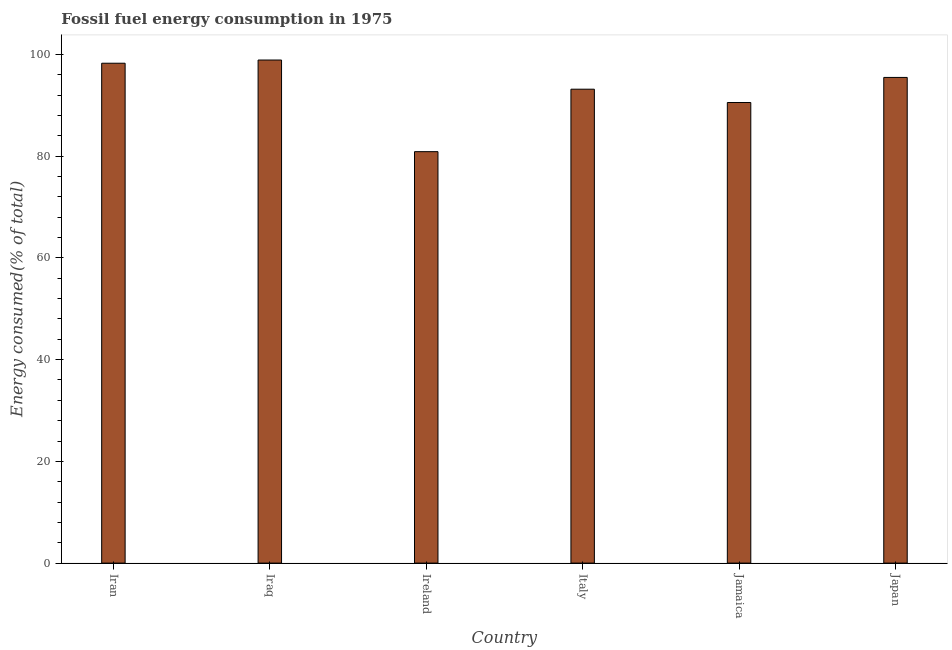What is the title of the graph?
Offer a terse response. Fossil fuel energy consumption in 1975. What is the label or title of the Y-axis?
Keep it short and to the point. Energy consumed(% of total). What is the fossil fuel energy consumption in Italy?
Make the answer very short. 93.16. Across all countries, what is the maximum fossil fuel energy consumption?
Offer a very short reply. 98.9. Across all countries, what is the minimum fossil fuel energy consumption?
Provide a short and direct response. 80.88. In which country was the fossil fuel energy consumption maximum?
Your answer should be compact. Iraq. In which country was the fossil fuel energy consumption minimum?
Provide a succinct answer. Ireland. What is the sum of the fossil fuel energy consumption?
Give a very brief answer. 557.23. What is the difference between the fossil fuel energy consumption in Iraq and Italy?
Offer a terse response. 5.73. What is the average fossil fuel energy consumption per country?
Your answer should be very brief. 92.87. What is the median fossil fuel energy consumption?
Provide a short and direct response. 94.32. What is the ratio of the fossil fuel energy consumption in Iraq to that in Jamaica?
Your response must be concise. 1.09. What is the difference between the highest and the second highest fossil fuel energy consumption?
Keep it short and to the point. 0.63. Is the sum of the fossil fuel energy consumption in Iraq and Italy greater than the maximum fossil fuel energy consumption across all countries?
Offer a terse response. Yes. What is the difference between the highest and the lowest fossil fuel energy consumption?
Your answer should be compact. 18.01. In how many countries, is the fossil fuel energy consumption greater than the average fossil fuel energy consumption taken over all countries?
Offer a very short reply. 4. How many countries are there in the graph?
Offer a very short reply. 6. Are the values on the major ticks of Y-axis written in scientific E-notation?
Your answer should be very brief. No. What is the Energy consumed(% of total) in Iran?
Provide a short and direct response. 98.27. What is the Energy consumed(% of total) in Iraq?
Give a very brief answer. 98.9. What is the Energy consumed(% of total) in Ireland?
Your answer should be very brief. 80.88. What is the Energy consumed(% of total) in Italy?
Give a very brief answer. 93.16. What is the Energy consumed(% of total) of Jamaica?
Your answer should be very brief. 90.54. What is the Energy consumed(% of total) of Japan?
Provide a short and direct response. 95.47. What is the difference between the Energy consumed(% of total) in Iran and Iraq?
Provide a short and direct response. -0.63. What is the difference between the Energy consumed(% of total) in Iran and Ireland?
Provide a succinct answer. 17.39. What is the difference between the Energy consumed(% of total) in Iran and Italy?
Provide a short and direct response. 5.11. What is the difference between the Energy consumed(% of total) in Iran and Jamaica?
Offer a very short reply. 7.72. What is the difference between the Energy consumed(% of total) in Iran and Japan?
Offer a terse response. 2.79. What is the difference between the Energy consumed(% of total) in Iraq and Ireland?
Make the answer very short. 18.01. What is the difference between the Energy consumed(% of total) in Iraq and Italy?
Your answer should be very brief. 5.73. What is the difference between the Energy consumed(% of total) in Iraq and Jamaica?
Your response must be concise. 8.35. What is the difference between the Energy consumed(% of total) in Iraq and Japan?
Your answer should be very brief. 3.42. What is the difference between the Energy consumed(% of total) in Ireland and Italy?
Keep it short and to the point. -12.28. What is the difference between the Energy consumed(% of total) in Ireland and Jamaica?
Ensure brevity in your answer.  -9.66. What is the difference between the Energy consumed(% of total) in Ireland and Japan?
Offer a very short reply. -14.59. What is the difference between the Energy consumed(% of total) in Italy and Jamaica?
Ensure brevity in your answer.  2.62. What is the difference between the Energy consumed(% of total) in Italy and Japan?
Ensure brevity in your answer.  -2.31. What is the difference between the Energy consumed(% of total) in Jamaica and Japan?
Your response must be concise. -4.93. What is the ratio of the Energy consumed(% of total) in Iran to that in Ireland?
Provide a short and direct response. 1.22. What is the ratio of the Energy consumed(% of total) in Iran to that in Italy?
Provide a succinct answer. 1.05. What is the ratio of the Energy consumed(% of total) in Iran to that in Jamaica?
Provide a succinct answer. 1.08. What is the ratio of the Energy consumed(% of total) in Iran to that in Japan?
Your answer should be compact. 1.03. What is the ratio of the Energy consumed(% of total) in Iraq to that in Ireland?
Offer a terse response. 1.22. What is the ratio of the Energy consumed(% of total) in Iraq to that in Italy?
Keep it short and to the point. 1.06. What is the ratio of the Energy consumed(% of total) in Iraq to that in Jamaica?
Provide a short and direct response. 1.09. What is the ratio of the Energy consumed(% of total) in Iraq to that in Japan?
Ensure brevity in your answer.  1.04. What is the ratio of the Energy consumed(% of total) in Ireland to that in Italy?
Your response must be concise. 0.87. What is the ratio of the Energy consumed(% of total) in Ireland to that in Jamaica?
Keep it short and to the point. 0.89. What is the ratio of the Energy consumed(% of total) in Ireland to that in Japan?
Your answer should be very brief. 0.85. What is the ratio of the Energy consumed(% of total) in Italy to that in Jamaica?
Make the answer very short. 1.03. What is the ratio of the Energy consumed(% of total) in Jamaica to that in Japan?
Provide a short and direct response. 0.95. 